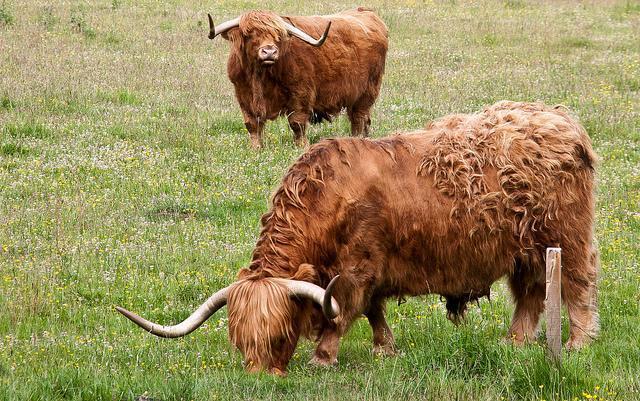How many cows can you see?
Give a very brief answer. 2. 